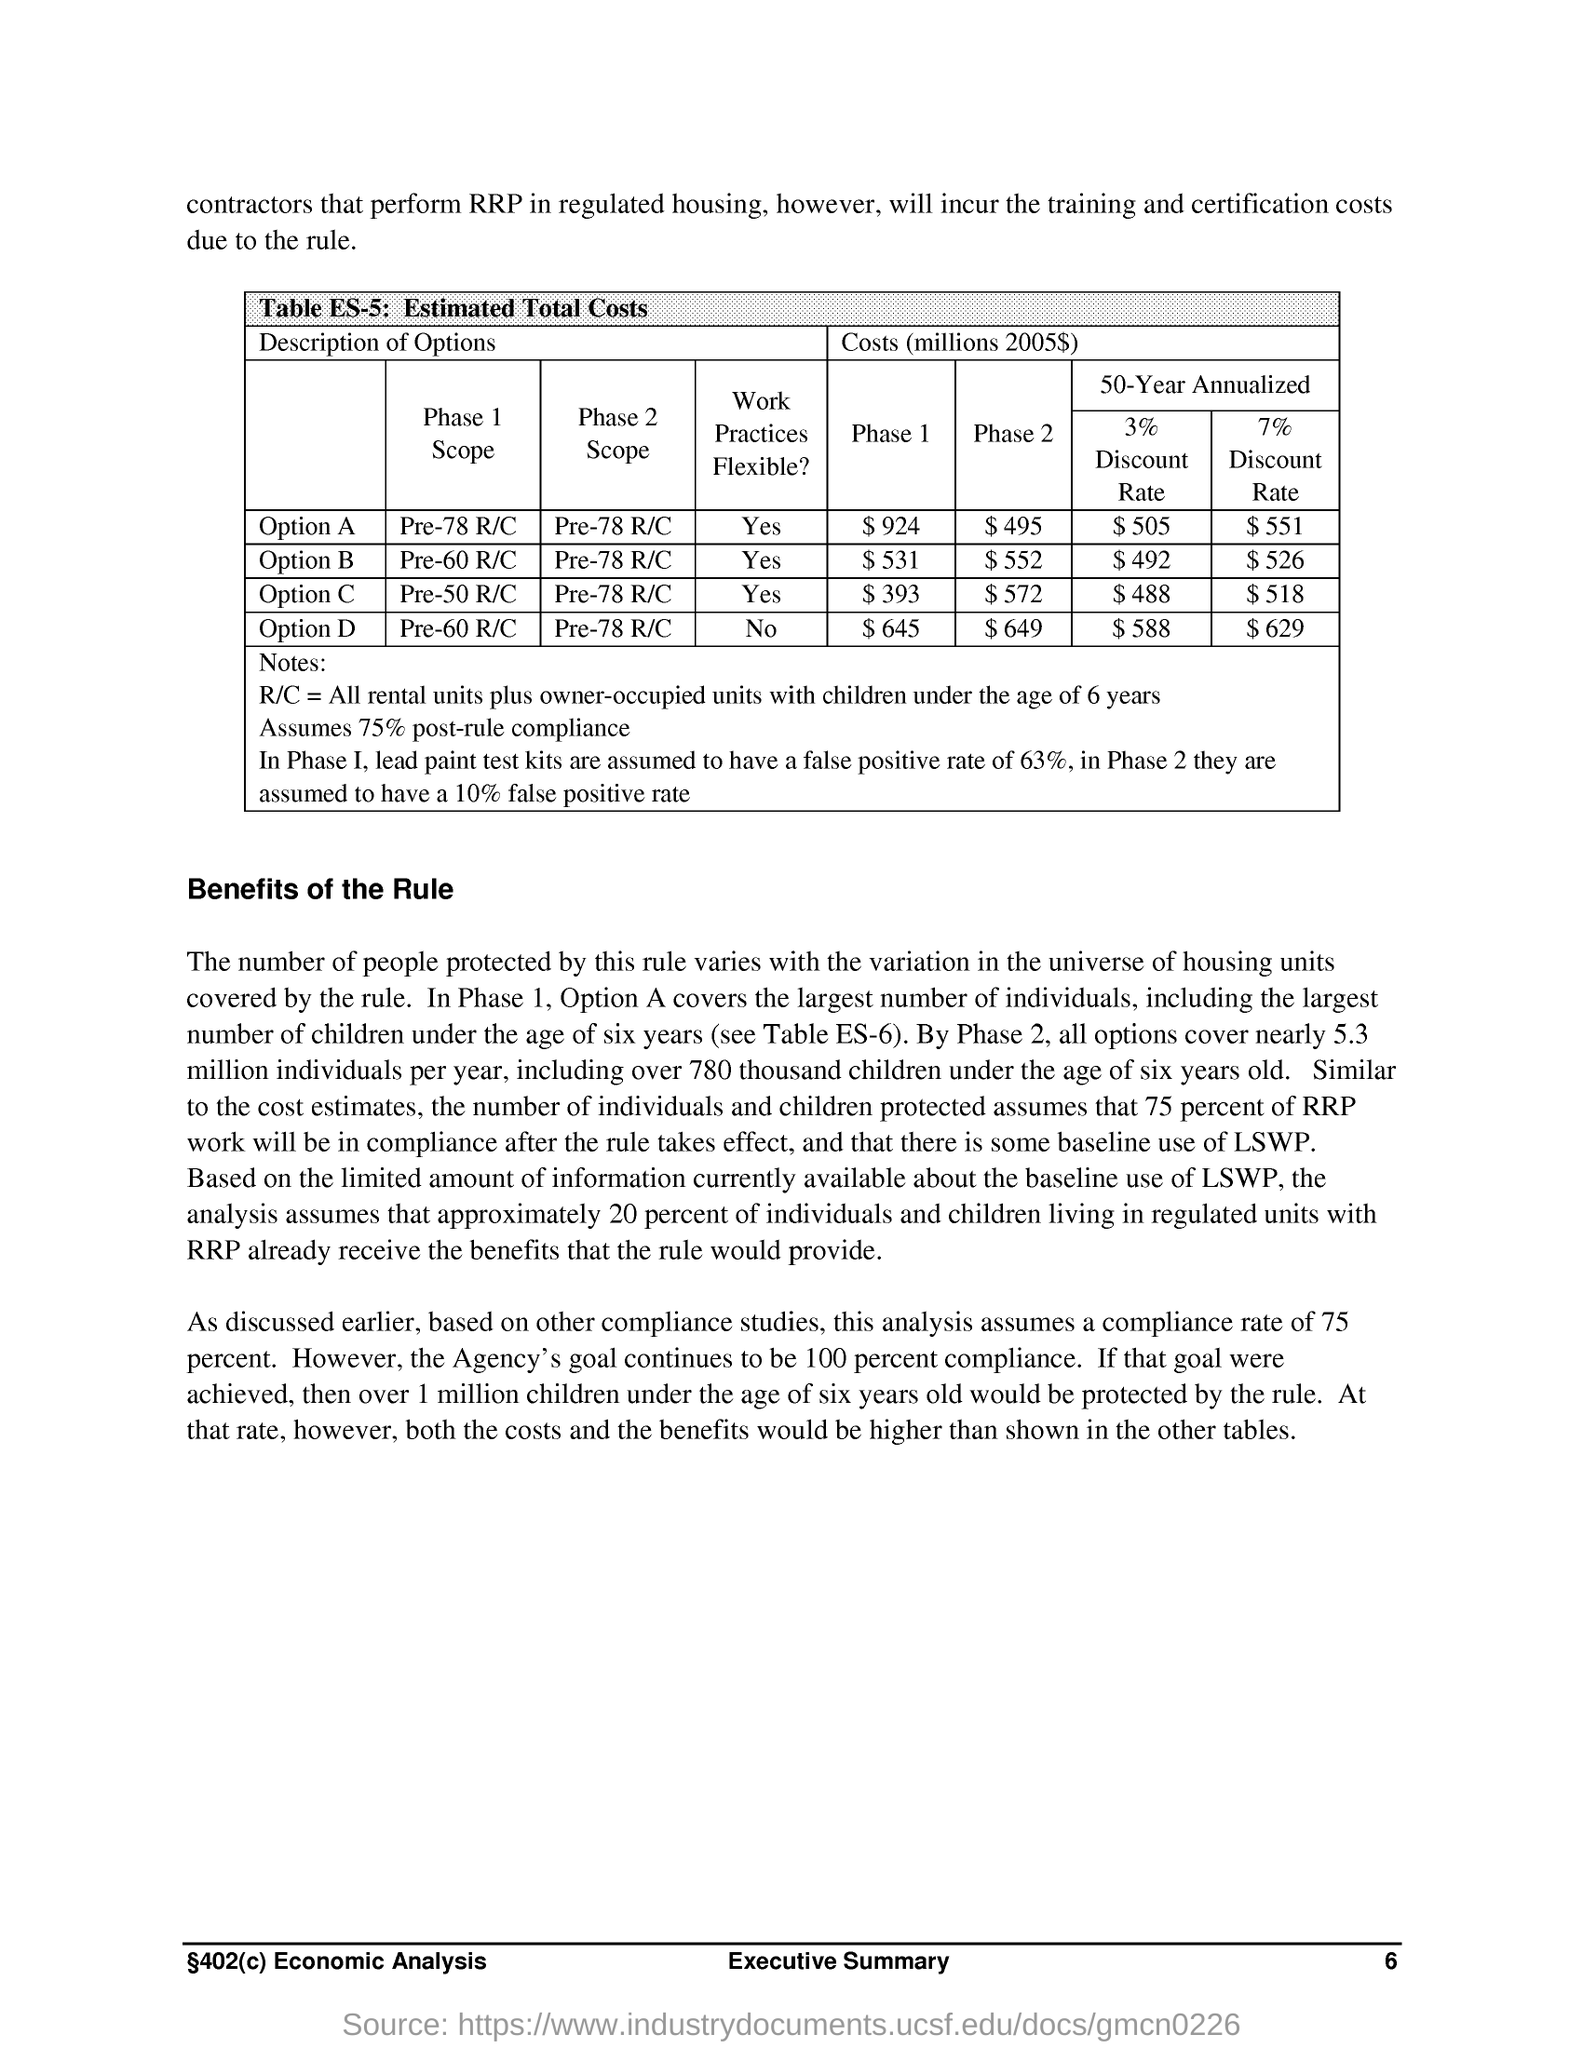Outline some significant characteristics in this image. The assumed compliance rate for this analysis is 75% post-rule compliance. 